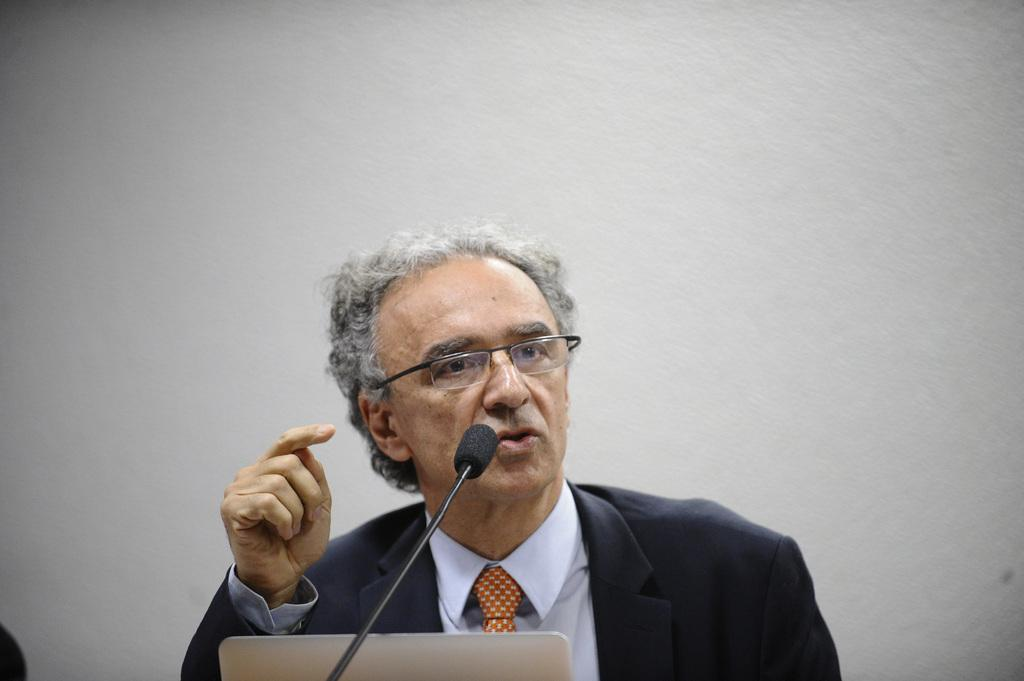Who is the main subject in the image? There is a man in the image. What is the man doing in the image? The man is talking on a microphone. What electronic device is visible at the bottom of the image? There is a laptop at the bottom of the image. What can be seen in the background of the image? There is a wall in the background of the image. Can you see the man's toes in the image? There is no indication of the man's toes being visible in the image. 